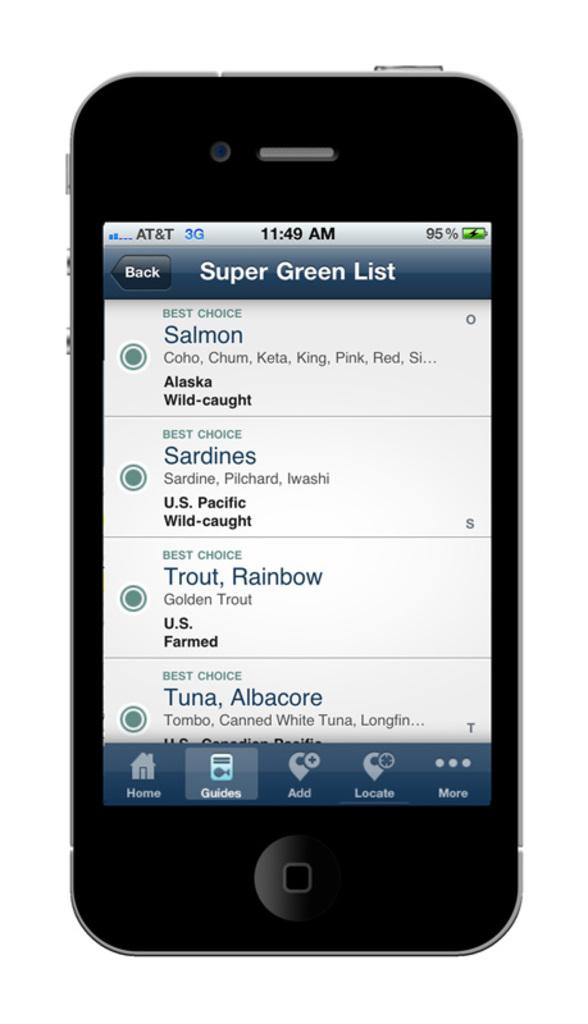Provide a one-sentence caption for the provided image. A phone is open to an app, containing the Super Green List. 